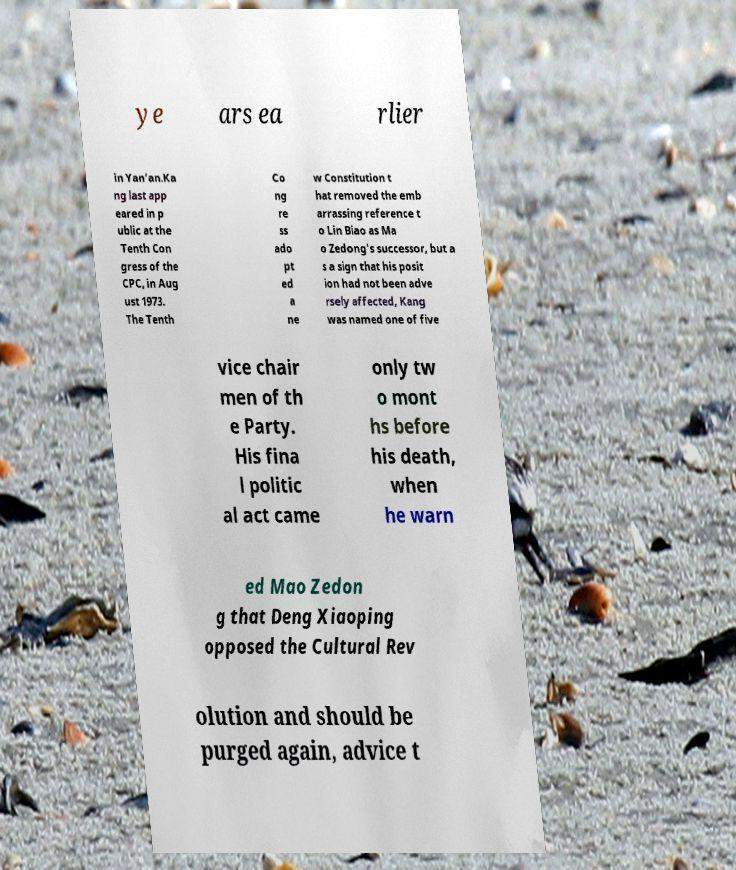I need the written content from this picture converted into text. Can you do that? ye ars ea rlier in Yan'an.Ka ng last app eared in p ublic at the Tenth Con gress of the CPC, in Aug ust 1973. The Tenth Co ng re ss ado pt ed a ne w Constitution t hat removed the emb arrassing reference t o Lin Biao as Ma o Zedong's successor, but a s a sign that his posit ion had not been adve rsely affected, Kang was named one of five vice chair men of th e Party. His fina l politic al act came only tw o mont hs before his death, when he warn ed Mao Zedon g that Deng Xiaoping opposed the Cultural Rev olution and should be purged again, advice t 